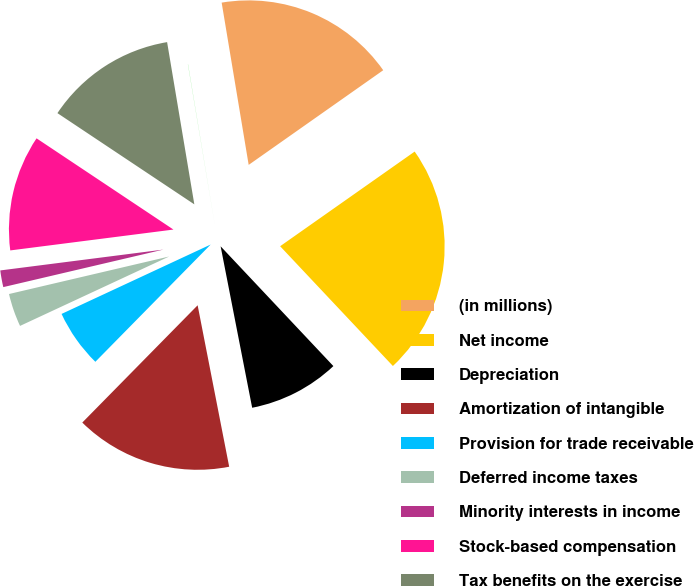Convert chart. <chart><loc_0><loc_0><loc_500><loc_500><pie_chart><fcel>(in millions)<fcel>Net income<fcel>Depreciation<fcel>Amortization of intangible<fcel>Provision for trade receivable<fcel>Deferred income taxes<fcel>Minority interests in income<fcel>Stock-based compensation<fcel>Tax benefits on the exercise<fcel>In-process research and<nl><fcel>17.87%<fcel>22.74%<fcel>8.95%<fcel>15.44%<fcel>5.7%<fcel>3.27%<fcel>1.64%<fcel>11.38%<fcel>13.0%<fcel>0.02%<nl></chart> 